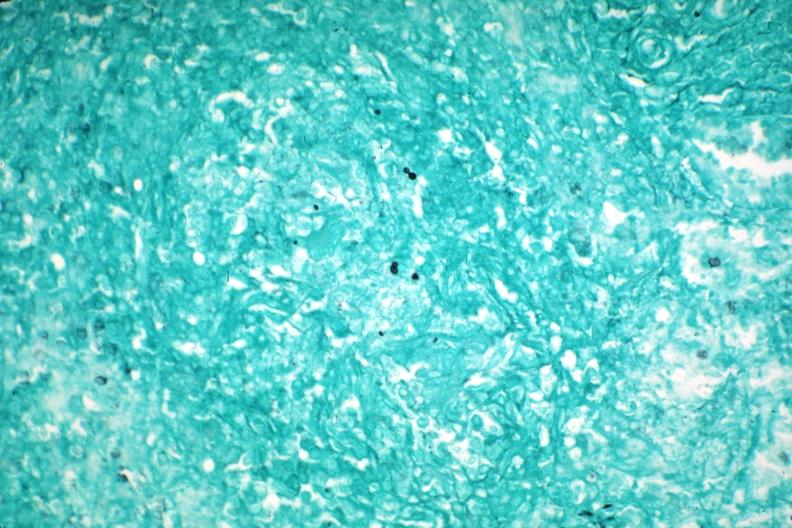does metastatic carcinoma show gms granuloma due to pneumocystis aids case?
Answer the question using a single word or phrase. No 